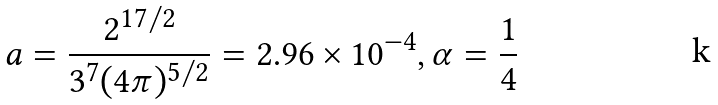Convert formula to latex. <formula><loc_0><loc_0><loc_500><loc_500>a = \frac { 2 ^ { 1 7 / 2 } } { 3 ^ { 7 } ( 4 \pi ) ^ { 5 / 2 } } = 2 . 9 6 \times 1 0 ^ { - 4 } , \alpha = \frac { 1 } { 4 }</formula> 